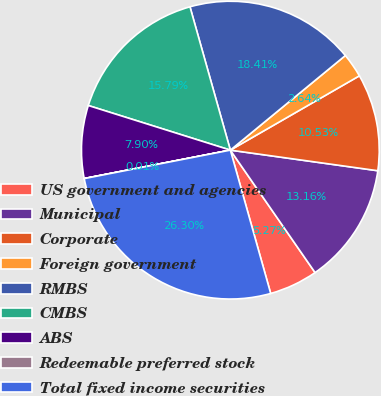Convert chart. <chart><loc_0><loc_0><loc_500><loc_500><pie_chart><fcel>US government and agencies<fcel>Municipal<fcel>Corporate<fcel>Foreign government<fcel>RMBS<fcel>CMBS<fcel>ABS<fcel>Redeemable preferred stock<fcel>Total fixed income securities<nl><fcel>5.27%<fcel>13.16%<fcel>10.53%<fcel>2.64%<fcel>18.42%<fcel>15.79%<fcel>7.9%<fcel>0.01%<fcel>26.31%<nl></chart> 